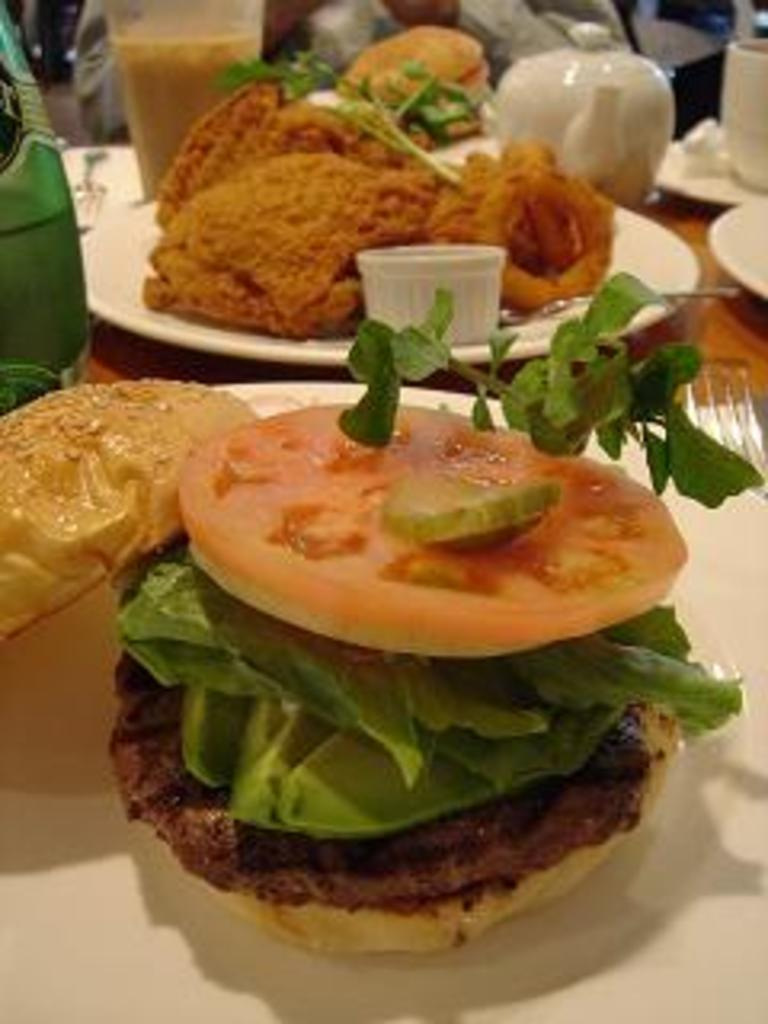What type of material is the surface in the image made of? The surface in the image is wooden. What can be seen on the wooden surface? There are white planes on the wooden surface. What is the food item on the plate in the image? The food item on the plate is not specified, but it is present on the plate. What other objects can be seen in the image besides the wooden surface and the plate? There is a pot, a glass, and a bottle in the image. What flavor of ice cream does the uncle in the image prefer? There is no mention of ice cream, flavor, or an uncle in the image, so this information cannot be determined. 